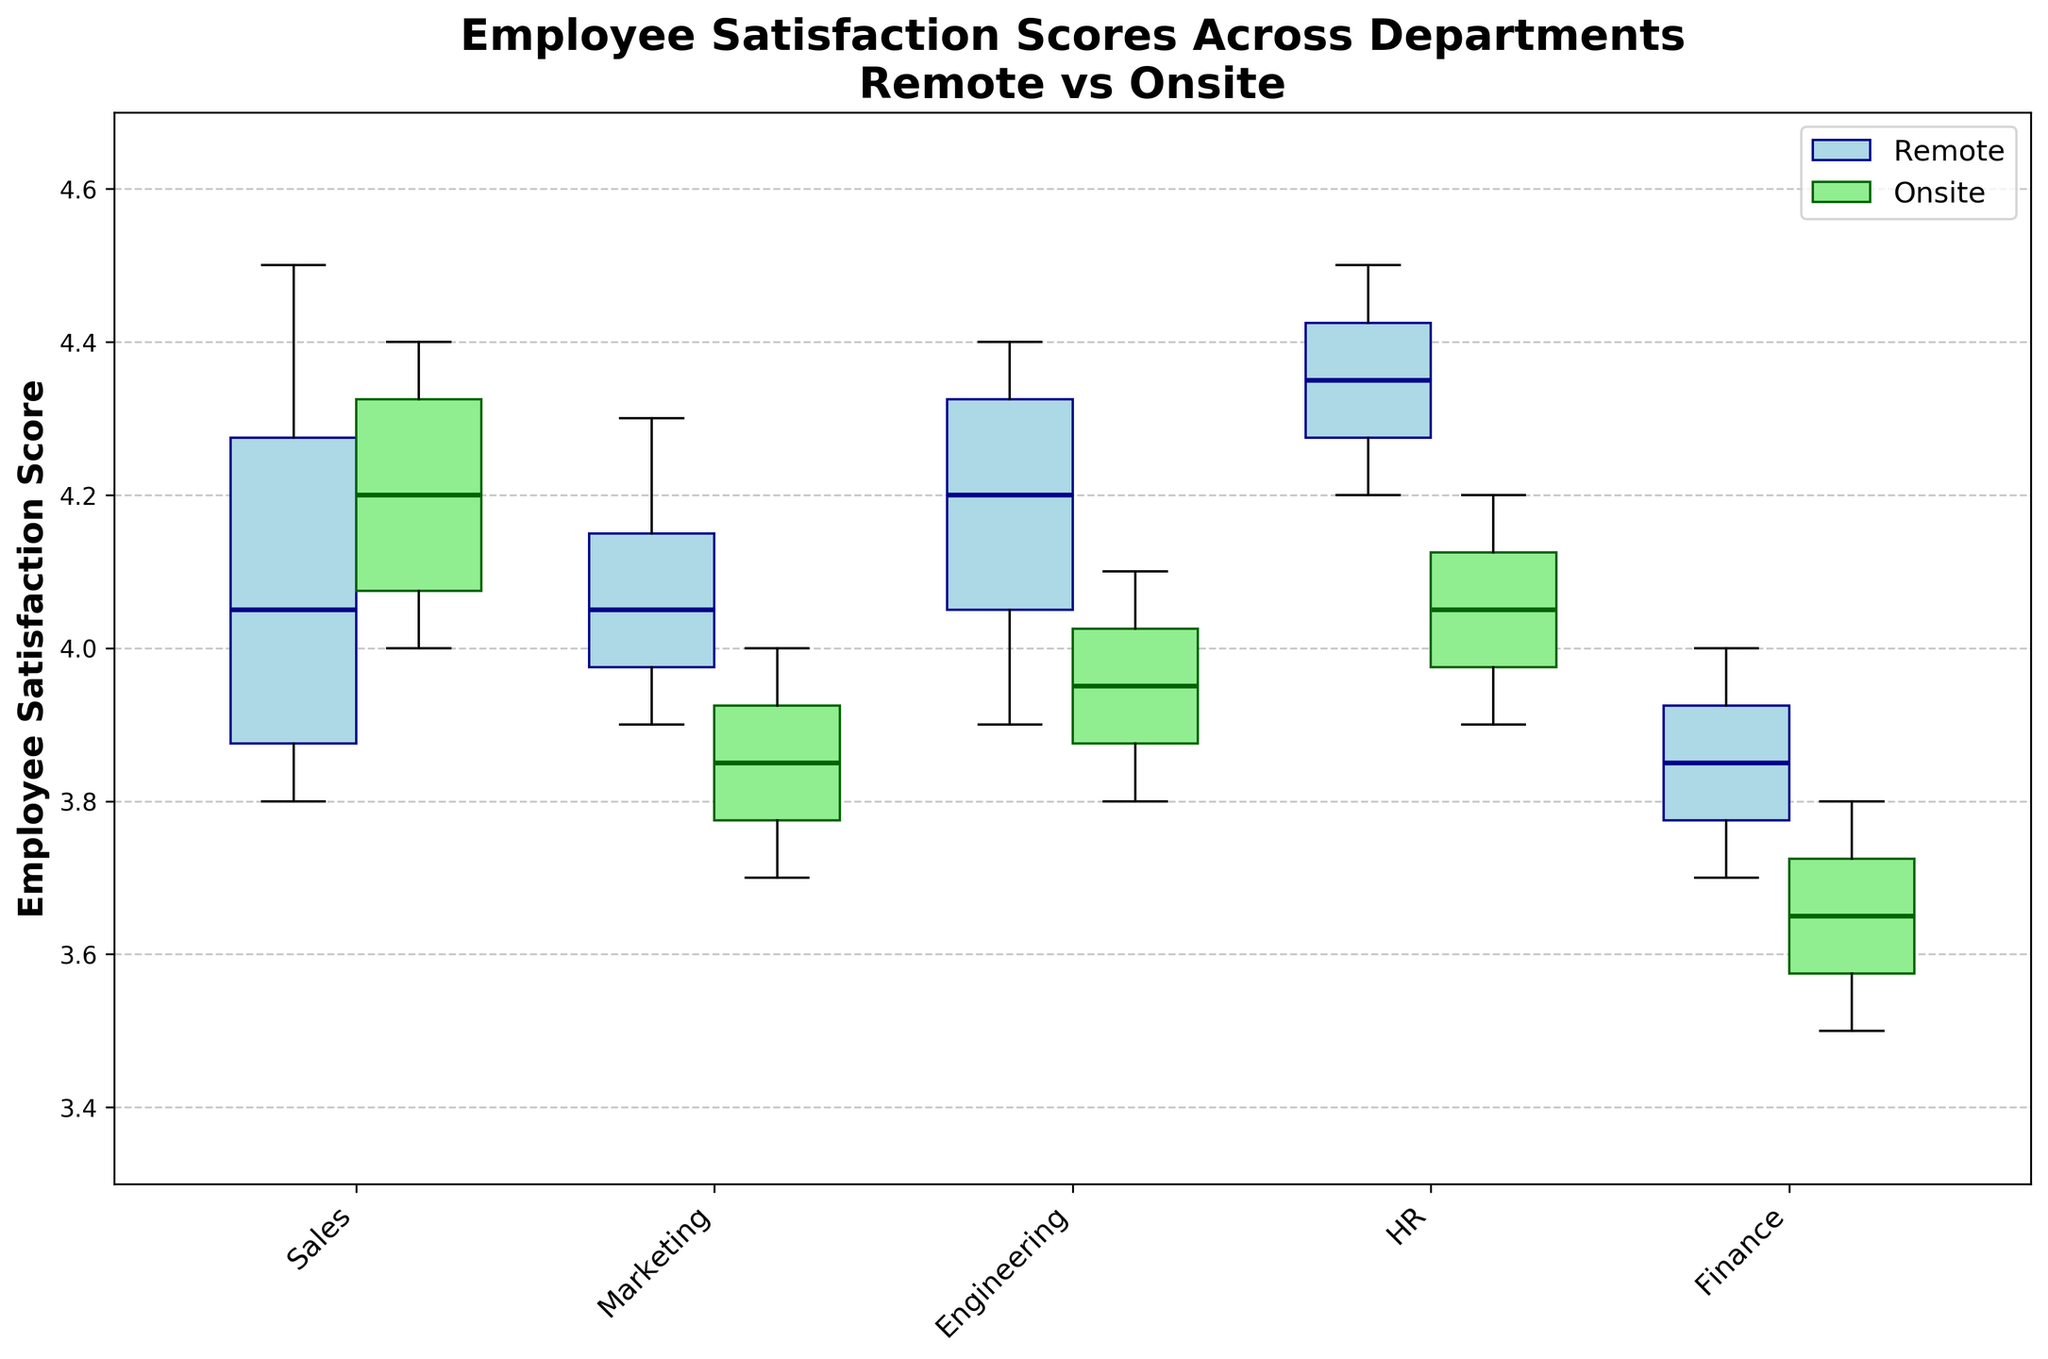What is the title of the figure? The title of the figure is located at the top. It provides a summary of what the figure is about, which in this case is "Employee Satisfaction Scores Across Departments\nRemote vs Onsite".
Answer: Employee Satisfaction Scores Across Departments\nRemote vs Onsite Which department has the highest median satisfaction score in the remote work setting? To find the highest median satisfaction score in the remote setting, compare the midlines of each remote box plot across departments. The department with the highest median line is HR.
Answer: HR What is the difference in the median satisfaction scores between remote and onsite settings for the Engineering department? First, identify the median satisfaction scores for both remote and onsite settings in the Engineering department, then calculate the difference. The remote median is around 4.2 and the onsite median is around 3.9. The difference is 4.2 - 3.9.
Answer: 0.3 Compare the variation in satisfaction scores (IQR) between remote and onsite settings in the Finance department. Which one is higher? The variation in a box plot is indicated by the IQR (Interquartile Range), which is the distance between the first and third quartiles. By visually comparing the lengths of the boxes for Finance department in remote and onsite settings, the onsite setting has a slightly smaller IQR. Thus, the remote setting has a higher variation.
Answer: Remote Which department shows the smallest interquartile range (IQR) for remote work settings? The smallest IQR can be identified by looking at the narrowest box in the remote work setting across all departments. HR shows the smallest IQR.
Answer: HR Is there any department where the median satisfaction score is higher in the onsite setting compared to the remote setting? To answer this, compare the medians in both settings for each department. None of the departments’ onsite medians exceed their remote medians.
Answer: No In which department do we see the greatest discrepancy between remote and onsite satisfaction scores in their range (difference between max and min scores)? To determine the greatest discrepancy in range between settings, compare the whiskers (minimum and maximum lines) of each department for both remote and onsite. The Finance department shows the greatest discrepancy in range.
Answer: Finance Looking at Marketing, is the median satisfaction score within the interquartile range of another department’s onsite setting? Check if the median satisfaction score for remote Marketing (around 4.0) falls within the boxes of onsite settings of other departments. It falls within the interquartile range of Sales and HR’s onsite settings.
Answer: Yes, Sales and HR Which work setting (Remote or Onsite) has a generally higher employee satisfaction in the Sales department? Compare the medians of remote and onsite in Sales. The remote median is generally higher than the onsite median.
Answer: Remote Across all departments, which remote work setting shows the lowest median satisfaction score? Identify the department with the lowest median line in remote work settings. Finance has the lowest median satisfaction score.
Answer: Finance 